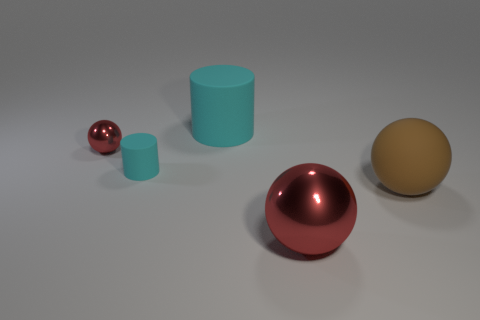There is a large cylinder that is to the left of the large brown matte sphere; what color is it?
Offer a terse response. Cyan. Is there a tiny matte thing that has the same color as the tiny cylinder?
Ensure brevity in your answer.  No. The metallic sphere that is the same size as the brown thing is what color?
Your answer should be compact. Red. Is the shape of the tiny red shiny object the same as the big brown matte thing?
Provide a short and direct response. Yes. There is a cylinder in front of the tiny ball; what material is it?
Provide a succinct answer. Rubber. The small rubber cylinder is what color?
Your response must be concise. Cyan. Do the sphere to the left of the large red ball and the metallic sphere that is on the right side of the large cyan object have the same size?
Offer a very short reply. No. What is the size of the ball that is both on the left side of the large brown rubber object and on the right side of the large cyan rubber cylinder?
Your answer should be compact. Large. What is the color of the small matte thing that is the same shape as the large cyan matte object?
Keep it short and to the point. Cyan. Is the number of objects in front of the small red metal ball greater than the number of big rubber cylinders in front of the big cyan object?
Provide a succinct answer. Yes. 